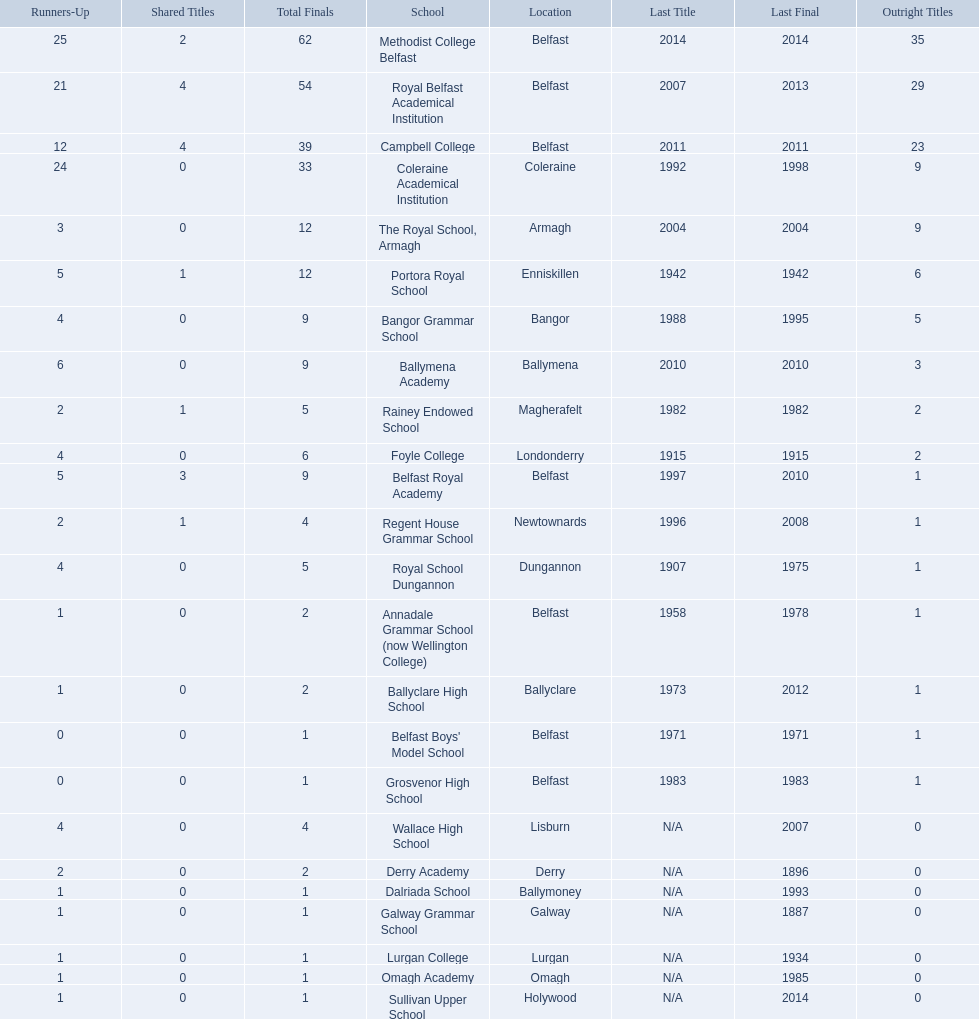What were all of the school names? Methodist College Belfast, Royal Belfast Academical Institution, Campbell College, Coleraine Academical Institution, The Royal School, Armagh, Portora Royal School, Bangor Grammar School, Ballymena Academy, Rainey Endowed School, Foyle College, Belfast Royal Academy, Regent House Grammar School, Royal School Dungannon, Annadale Grammar School (now Wellington College), Ballyclare High School, Belfast Boys' Model School, Grosvenor High School, Wallace High School, Derry Academy, Dalriada School, Galway Grammar School, Lurgan College, Omagh Academy, Sullivan Upper School. How many outright titles did they achieve? 35, 29, 23, 9, 9, 6, 5, 3, 2, 2, 1, 1, 1, 1, 1, 1, 1, 0, 0, 0, 0, 0, 0, 0. And how many did coleraine academical institution receive? 9. Which other school had the same number of outright titles? The Royal School, Armagh. 